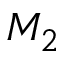<formula> <loc_0><loc_0><loc_500><loc_500>M _ { 2 }</formula> 